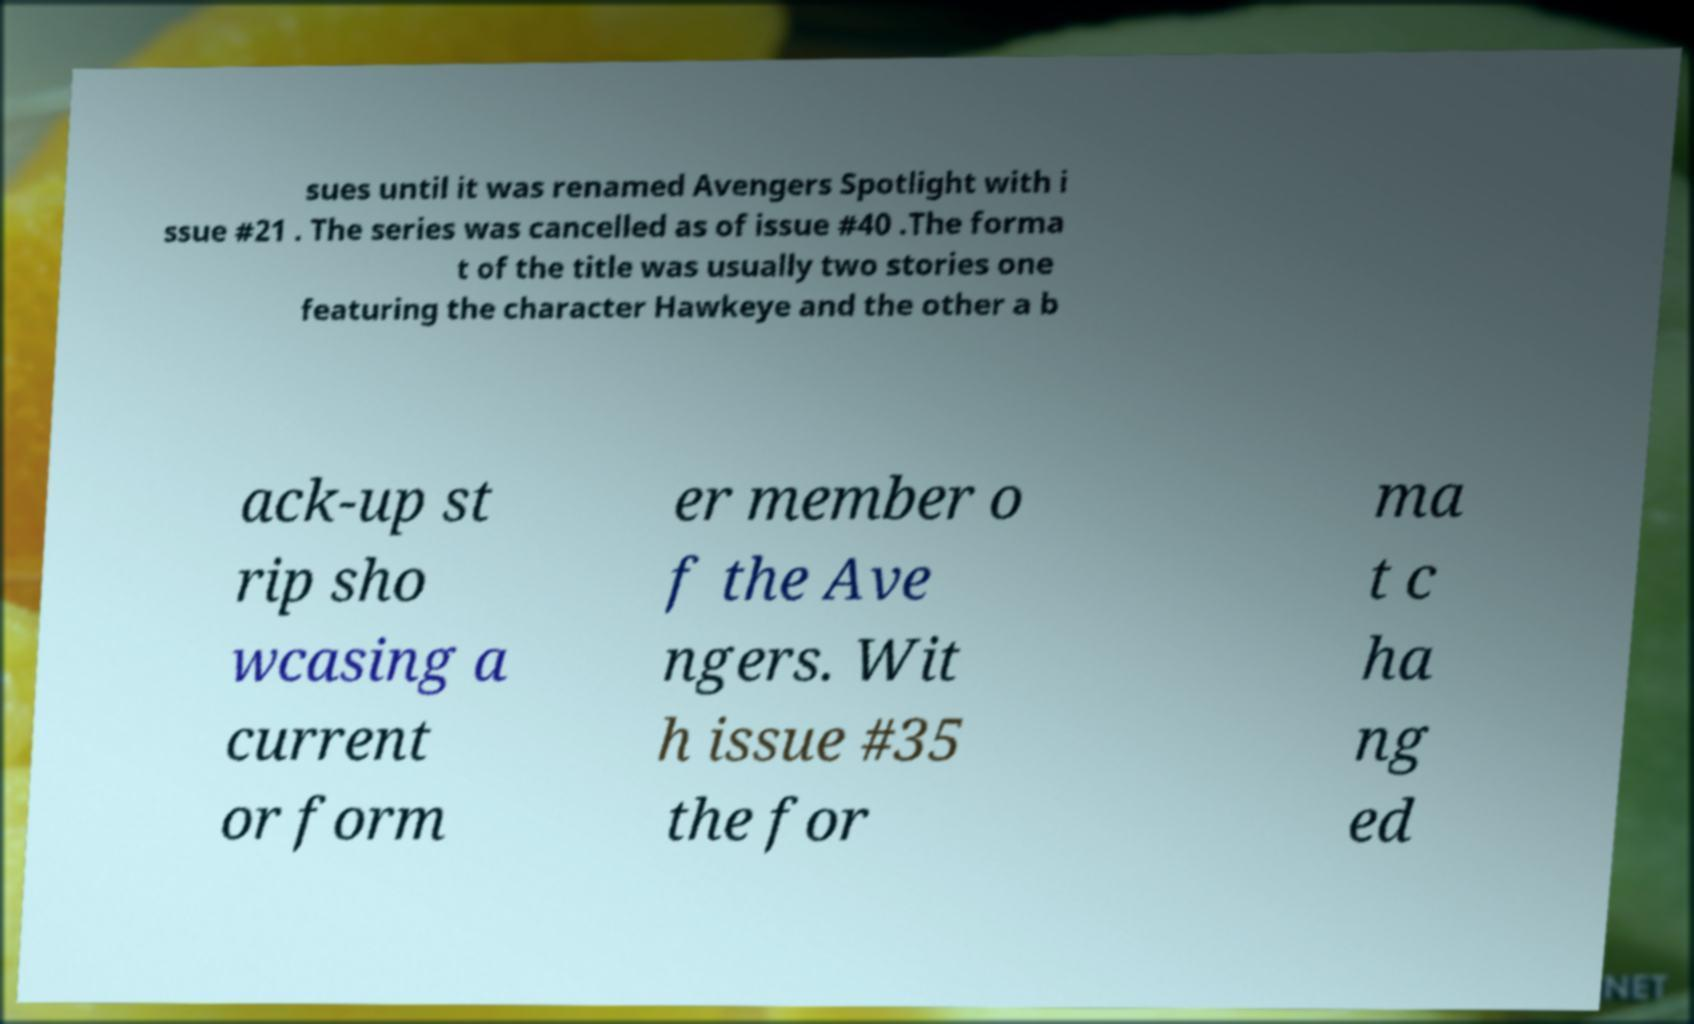I need the written content from this picture converted into text. Can you do that? sues until it was renamed Avengers Spotlight with i ssue #21 . The series was cancelled as of issue #40 .The forma t of the title was usually two stories one featuring the character Hawkeye and the other a b ack-up st rip sho wcasing a current or form er member o f the Ave ngers. Wit h issue #35 the for ma t c ha ng ed 